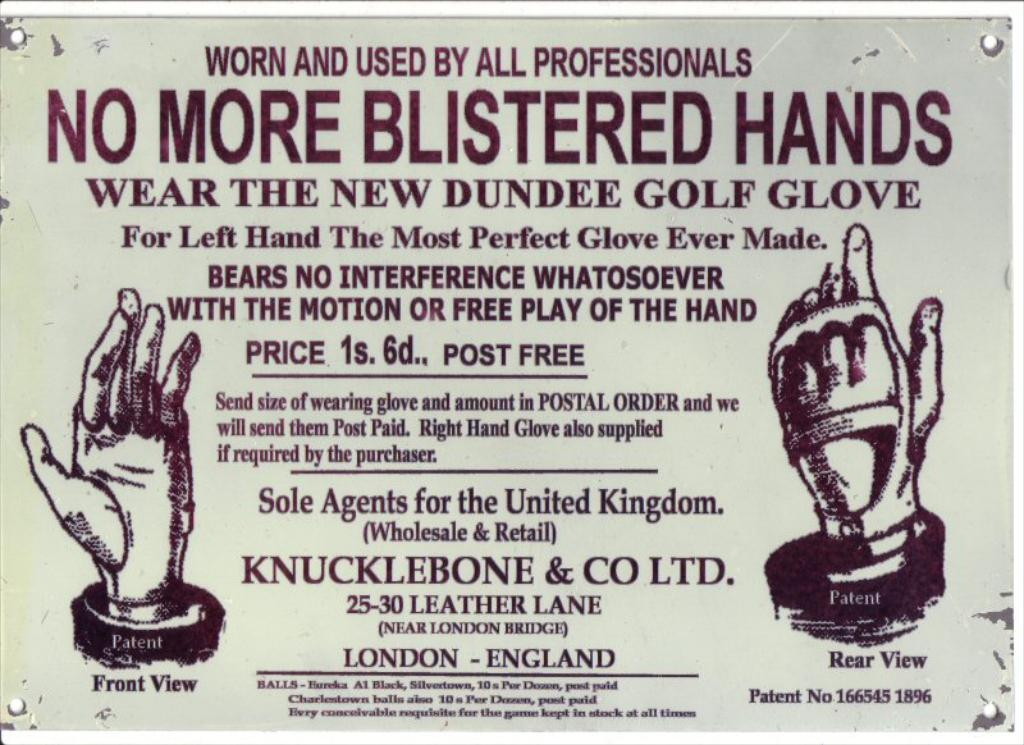<image>
Write a terse but informative summary of the picture. Dundee Golf Gloves are suitable for left handed players. 